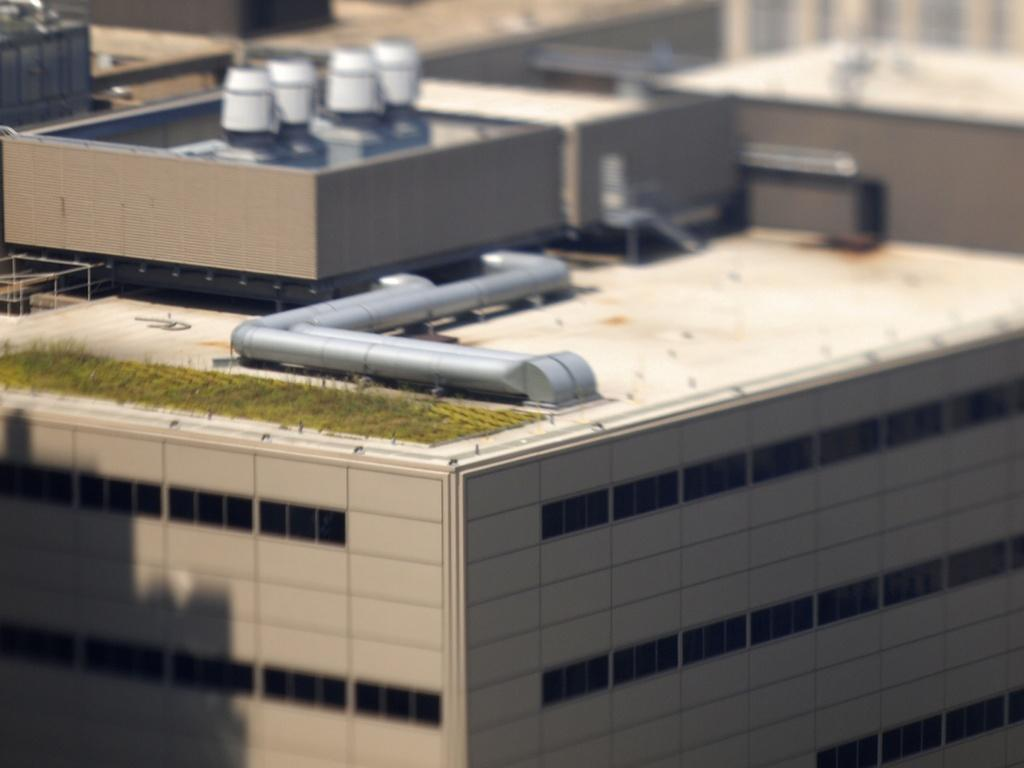What is the main structure visible in the image? There is a building in the image. What else can be seen in the image besides the building? There are pipes visible in the image. Can you describe the background of the image? The background of the image appears blurry. How does the guide help people navigate through the rainstorm in the image? There is no guide or rainstorm present in the image; it only features a building and pipes. 